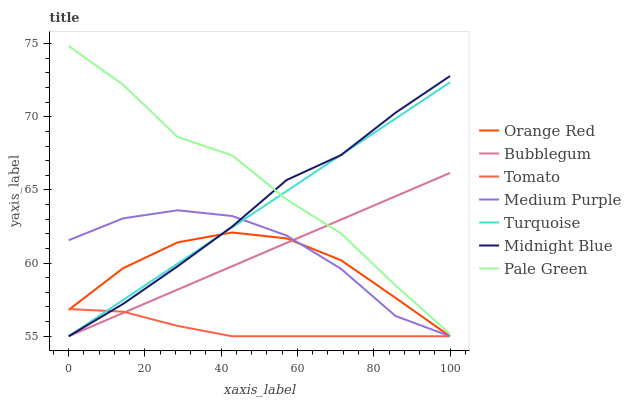Does Turquoise have the minimum area under the curve?
Answer yes or no. No. Does Turquoise have the maximum area under the curve?
Answer yes or no. No. Is Midnight Blue the smoothest?
Answer yes or no. No. Is Midnight Blue the roughest?
Answer yes or no. No. Does Pale Green have the lowest value?
Answer yes or no. No. Does Turquoise have the highest value?
Answer yes or no. No. Is Orange Red less than Pale Green?
Answer yes or no. Yes. Is Pale Green greater than Tomato?
Answer yes or no. Yes. Does Orange Red intersect Pale Green?
Answer yes or no. No. 